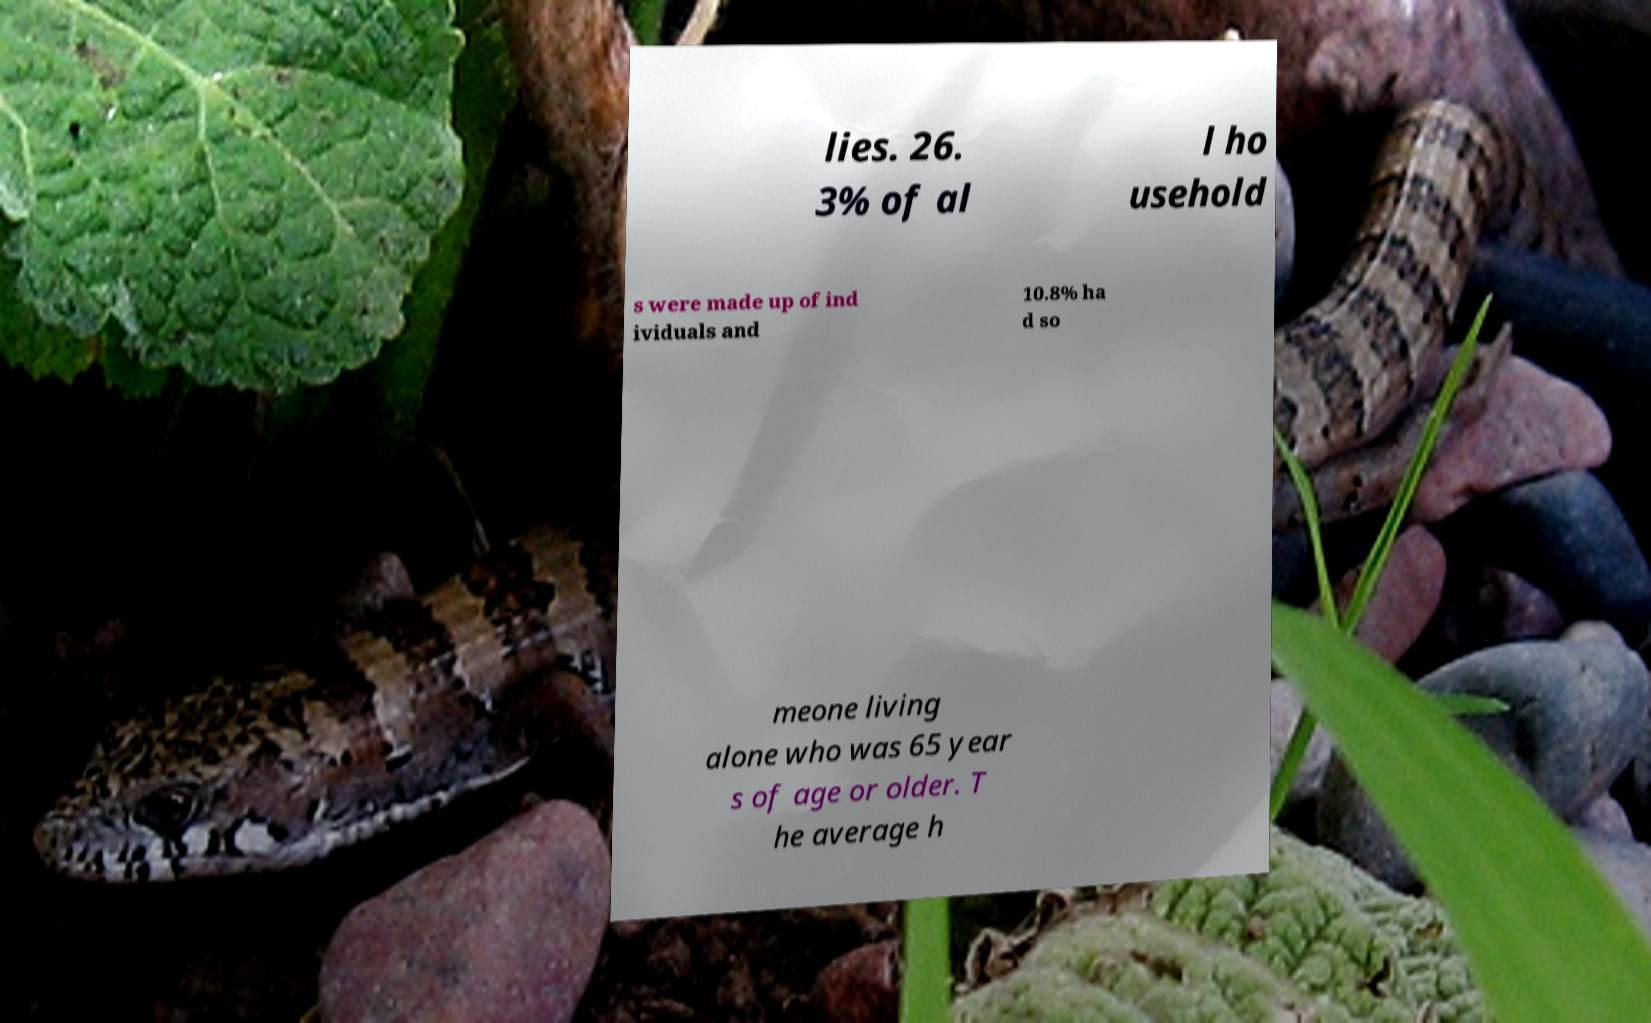Please identify and transcribe the text found in this image. lies. 26. 3% of al l ho usehold s were made up of ind ividuals and 10.8% ha d so meone living alone who was 65 year s of age or older. T he average h 